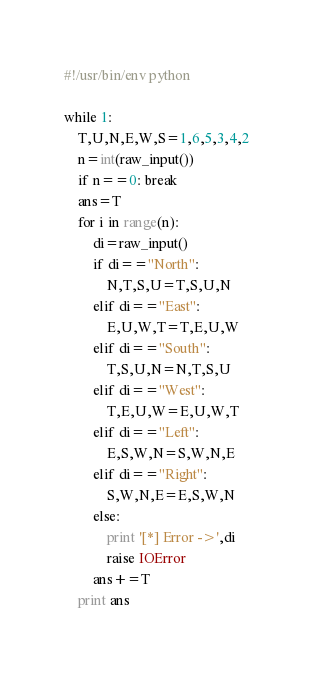<code> <loc_0><loc_0><loc_500><loc_500><_Python_>#!/usr/bin/env python

while 1:
    T,U,N,E,W,S=1,6,5,3,4,2
    n=int(raw_input())
    if n==0: break
    ans=T
    for i in range(n):
        di=raw_input()
        if di=="North":
            N,T,S,U=T,S,U,N
        elif di=="East":
            E,U,W,T=T,E,U,W
        elif di=="South":
            T,S,U,N=N,T,S,U
        elif di=="West":
            T,E,U,W=E,U,W,T
        elif di=="Left":
            E,S,W,N=S,W,N,E
        elif di=="Right":
            S,W,N,E=E,S,W,N
        else:
            print '[*] Error ->',di
            raise IOError
        ans+=T
    print ans</code> 